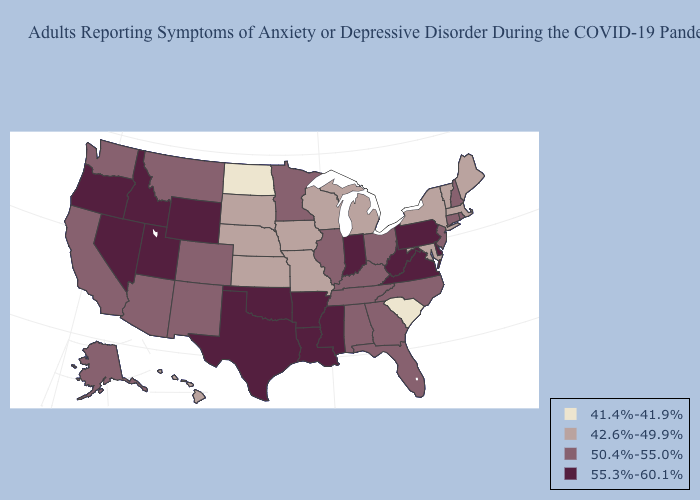Name the states that have a value in the range 41.4%-41.9%?
Short answer required. North Dakota, South Carolina. Does Hawaii have the lowest value in the West?
Be succinct. Yes. Among the states that border Kentucky , does Illinois have the highest value?
Short answer required. No. What is the lowest value in the USA?
Give a very brief answer. 41.4%-41.9%. Name the states that have a value in the range 50.4%-55.0%?
Concise answer only. Alabama, Alaska, Arizona, California, Colorado, Connecticut, Florida, Georgia, Illinois, Kentucky, Minnesota, Montana, New Hampshire, New Jersey, New Mexico, North Carolina, Ohio, Rhode Island, Tennessee, Washington. What is the value of North Dakota?
Short answer required. 41.4%-41.9%. What is the value of Delaware?
Concise answer only. 55.3%-60.1%. Does Oregon have the highest value in the West?
Quick response, please. Yes. Which states have the highest value in the USA?
Concise answer only. Arkansas, Delaware, Idaho, Indiana, Louisiana, Mississippi, Nevada, Oklahoma, Oregon, Pennsylvania, Texas, Utah, Virginia, West Virginia, Wyoming. Name the states that have a value in the range 50.4%-55.0%?
Short answer required. Alabama, Alaska, Arizona, California, Colorado, Connecticut, Florida, Georgia, Illinois, Kentucky, Minnesota, Montana, New Hampshire, New Jersey, New Mexico, North Carolina, Ohio, Rhode Island, Tennessee, Washington. What is the value of West Virginia?
Keep it brief. 55.3%-60.1%. Does Missouri have the same value as Maryland?
Short answer required. Yes. Name the states that have a value in the range 42.6%-49.9%?
Give a very brief answer. Hawaii, Iowa, Kansas, Maine, Maryland, Massachusetts, Michigan, Missouri, Nebraska, New York, South Dakota, Vermont, Wisconsin. Name the states that have a value in the range 42.6%-49.9%?
Short answer required. Hawaii, Iowa, Kansas, Maine, Maryland, Massachusetts, Michigan, Missouri, Nebraska, New York, South Dakota, Vermont, Wisconsin. Which states have the lowest value in the USA?
Concise answer only. North Dakota, South Carolina. 